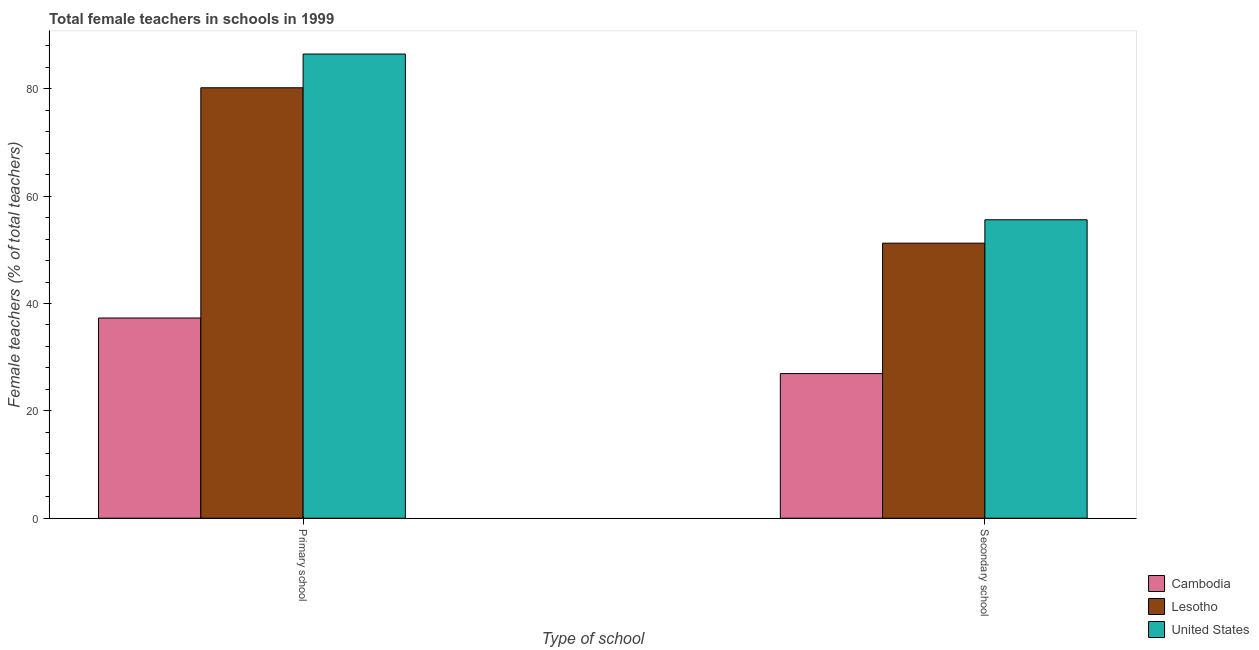How many different coloured bars are there?
Your answer should be compact. 3. What is the label of the 2nd group of bars from the left?
Give a very brief answer. Secondary school. What is the percentage of female teachers in primary schools in Lesotho?
Keep it short and to the point. 80.18. Across all countries, what is the maximum percentage of female teachers in secondary schools?
Provide a short and direct response. 55.6. Across all countries, what is the minimum percentage of female teachers in secondary schools?
Give a very brief answer. 26.94. In which country was the percentage of female teachers in secondary schools minimum?
Make the answer very short. Cambodia. What is the total percentage of female teachers in primary schools in the graph?
Your answer should be very brief. 203.95. What is the difference between the percentage of female teachers in primary schools in United States and that in Lesotho?
Your response must be concise. 6.29. What is the difference between the percentage of female teachers in primary schools in Cambodia and the percentage of female teachers in secondary schools in United States?
Offer a terse response. -18.3. What is the average percentage of female teachers in secondary schools per country?
Offer a terse response. 44.59. What is the difference between the percentage of female teachers in primary schools and percentage of female teachers in secondary schools in Lesotho?
Your response must be concise. 28.94. What is the ratio of the percentage of female teachers in secondary schools in Cambodia to that in United States?
Make the answer very short. 0.48. In how many countries, is the percentage of female teachers in primary schools greater than the average percentage of female teachers in primary schools taken over all countries?
Give a very brief answer. 2. What does the 1st bar from the left in Secondary school represents?
Your answer should be compact. Cambodia. What does the 3rd bar from the right in Primary school represents?
Give a very brief answer. Cambodia. How many countries are there in the graph?
Offer a very short reply. 3. What is the difference between two consecutive major ticks on the Y-axis?
Your response must be concise. 20. Are the values on the major ticks of Y-axis written in scientific E-notation?
Offer a very short reply. No. Does the graph contain any zero values?
Provide a succinct answer. No. Does the graph contain grids?
Offer a terse response. No. What is the title of the graph?
Your response must be concise. Total female teachers in schools in 1999. What is the label or title of the X-axis?
Make the answer very short. Type of school. What is the label or title of the Y-axis?
Provide a short and direct response. Female teachers (% of total teachers). What is the Female teachers (% of total teachers) of Cambodia in Primary school?
Your answer should be very brief. 37.3. What is the Female teachers (% of total teachers) in Lesotho in Primary school?
Your answer should be very brief. 80.18. What is the Female teachers (% of total teachers) of United States in Primary school?
Your response must be concise. 86.47. What is the Female teachers (% of total teachers) of Cambodia in Secondary school?
Offer a very short reply. 26.94. What is the Female teachers (% of total teachers) of Lesotho in Secondary school?
Ensure brevity in your answer.  51.24. What is the Female teachers (% of total teachers) of United States in Secondary school?
Keep it short and to the point. 55.6. Across all Type of school, what is the maximum Female teachers (% of total teachers) in Cambodia?
Keep it short and to the point. 37.3. Across all Type of school, what is the maximum Female teachers (% of total teachers) of Lesotho?
Provide a succinct answer. 80.18. Across all Type of school, what is the maximum Female teachers (% of total teachers) in United States?
Your answer should be compact. 86.47. Across all Type of school, what is the minimum Female teachers (% of total teachers) in Cambodia?
Ensure brevity in your answer.  26.94. Across all Type of school, what is the minimum Female teachers (% of total teachers) of Lesotho?
Provide a short and direct response. 51.24. Across all Type of school, what is the minimum Female teachers (% of total teachers) in United States?
Your response must be concise. 55.6. What is the total Female teachers (% of total teachers) of Cambodia in the graph?
Your answer should be very brief. 64.24. What is the total Female teachers (% of total teachers) of Lesotho in the graph?
Keep it short and to the point. 131.42. What is the total Female teachers (% of total teachers) in United States in the graph?
Offer a terse response. 142.06. What is the difference between the Female teachers (% of total teachers) in Cambodia in Primary school and that in Secondary school?
Your response must be concise. 10.35. What is the difference between the Female teachers (% of total teachers) in Lesotho in Primary school and that in Secondary school?
Provide a short and direct response. 28.94. What is the difference between the Female teachers (% of total teachers) in United States in Primary school and that in Secondary school?
Offer a terse response. 30.87. What is the difference between the Female teachers (% of total teachers) in Cambodia in Primary school and the Female teachers (% of total teachers) in Lesotho in Secondary school?
Ensure brevity in your answer.  -13.94. What is the difference between the Female teachers (% of total teachers) in Cambodia in Primary school and the Female teachers (% of total teachers) in United States in Secondary school?
Provide a succinct answer. -18.3. What is the difference between the Female teachers (% of total teachers) in Lesotho in Primary school and the Female teachers (% of total teachers) in United States in Secondary school?
Give a very brief answer. 24.59. What is the average Female teachers (% of total teachers) in Cambodia per Type of school?
Your response must be concise. 32.12. What is the average Female teachers (% of total teachers) in Lesotho per Type of school?
Give a very brief answer. 65.71. What is the average Female teachers (% of total teachers) of United States per Type of school?
Ensure brevity in your answer.  71.03. What is the difference between the Female teachers (% of total teachers) in Cambodia and Female teachers (% of total teachers) in Lesotho in Primary school?
Your response must be concise. -42.88. What is the difference between the Female teachers (% of total teachers) in Cambodia and Female teachers (% of total teachers) in United States in Primary school?
Offer a very short reply. -49.17. What is the difference between the Female teachers (% of total teachers) in Lesotho and Female teachers (% of total teachers) in United States in Primary school?
Ensure brevity in your answer.  -6.29. What is the difference between the Female teachers (% of total teachers) in Cambodia and Female teachers (% of total teachers) in Lesotho in Secondary school?
Your response must be concise. -24.3. What is the difference between the Female teachers (% of total teachers) in Cambodia and Female teachers (% of total teachers) in United States in Secondary school?
Ensure brevity in your answer.  -28.65. What is the difference between the Female teachers (% of total teachers) in Lesotho and Female teachers (% of total teachers) in United States in Secondary school?
Provide a short and direct response. -4.36. What is the ratio of the Female teachers (% of total teachers) of Cambodia in Primary school to that in Secondary school?
Provide a short and direct response. 1.38. What is the ratio of the Female teachers (% of total teachers) of Lesotho in Primary school to that in Secondary school?
Ensure brevity in your answer.  1.56. What is the ratio of the Female teachers (% of total teachers) in United States in Primary school to that in Secondary school?
Provide a short and direct response. 1.56. What is the difference between the highest and the second highest Female teachers (% of total teachers) in Cambodia?
Give a very brief answer. 10.35. What is the difference between the highest and the second highest Female teachers (% of total teachers) in Lesotho?
Keep it short and to the point. 28.94. What is the difference between the highest and the second highest Female teachers (% of total teachers) in United States?
Your response must be concise. 30.87. What is the difference between the highest and the lowest Female teachers (% of total teachers) in Cambodia?
Ensure brevity in your answer.  10.35. What is the difference between the highest and the lowest Female teachers (% of total teachers) in Lesotho?
Offer a very short reply. 28.94. What is the difference between the highest and the lowest Female teachers (% of total teachers) in United States?
Make the answer very short. 30.87. 